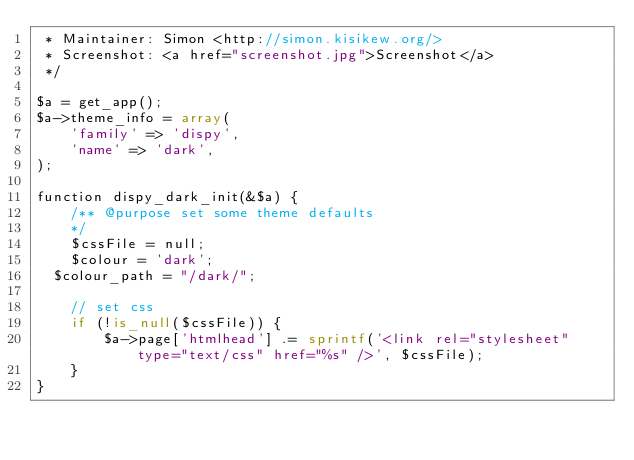Convert code to text. <code><loc_0><loc_0><loc_500><loc_500><_PHP_> * Maintainer: Simon <http://simon.kisikew.org/>
 * Screenshot: <a href="screenshot.jpg">Screenshot</a>
 */

$a = get_app();
$a->theme_info = array(
    'family' => 'dispy',
    'name' => 'dark',
);

function dispy_dark_init(&$a) {
    /** @purpose set some theme defaults
    */
    $cssFile = null;
    $colour = 'dark';
	$colour_path = "/dark/";

    // set css
    if (!is_null($cssFile)) {
        $a->page['htmlhead'] .= sprintf('<link rel="stylesheet" type="text/css" href="%s" />', $cssFile);
    }
}

</code> 